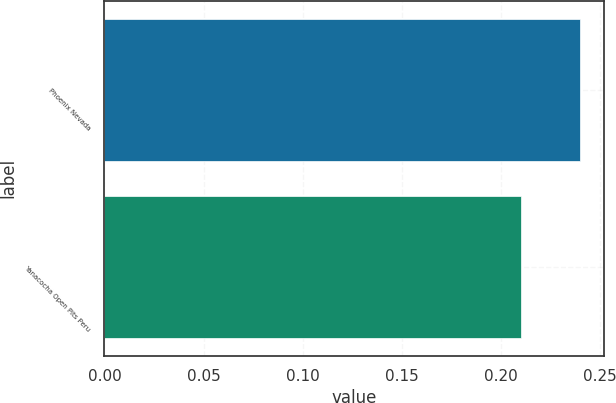<chart> <loc_0><loc_0><loc_500><loc_500><bar_chart><fcel>Phoenix Nevada<fcel>Yanacocha Open Pits Peru<nl><fcel>0.24<fcel>0.21<nl></chart> 